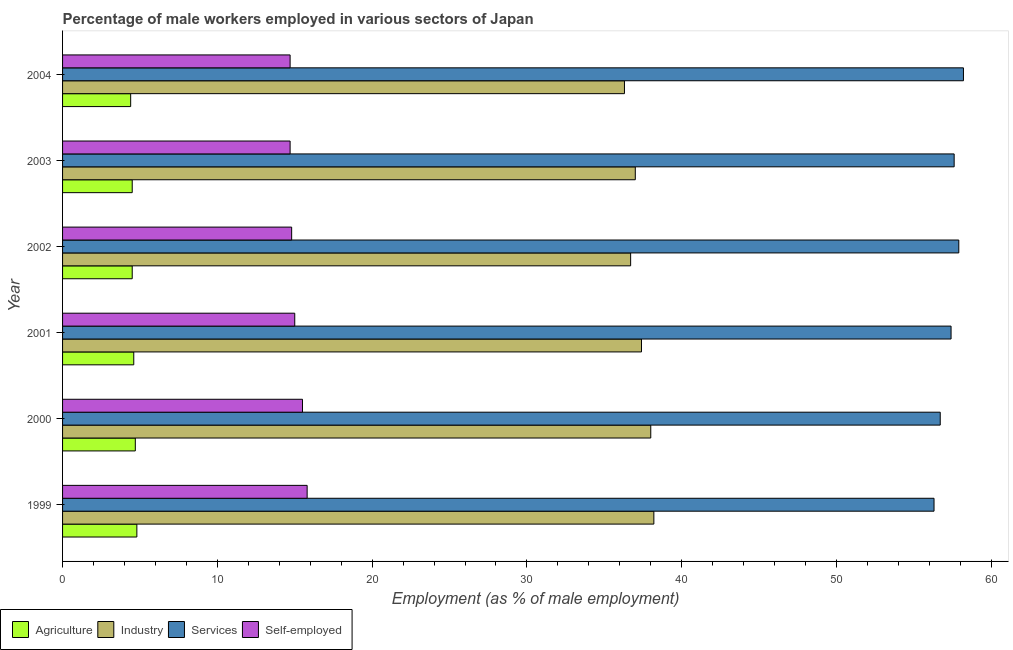How many groups of bars are there?
Your answer should be very brief. 6. Are the number of bars on each tick of the Y-axis equal?
Provide a succinct answer. Yes. What is the percentage of male workers in services in 2004?
Offer a very short reply. 58.2. Across all years, what is the maximum percentage of self employed male workers?
Give a very brief answer. 15.8. Across all years, what is the minimum percentage of male workers in agriculture?
Your answer should be compact. 4.4. In which year was the percentage of male workers in industry maximum?
Ensure brevity in your answer.  1999. What is the total percentage of male workers in agriculture in the graph?
Your answer should be compact. 27.5. What is the difference between the percentage of male workers in industry in 1999 and the percentage of male workers in services in 2001?
Ensure brevity in your answer.  -19.2. What is the average percentage of self employed male workers per year?
Provide a succinct answer. 15.08. In the year 2001, what is the difference between the percentage of male workers in agriculture and percentage of male workers in industry?
Your answer should be compact. -32.8. What is the ratio of the percentage of male workers in industry in 2002 to that in 2003?
Your answer should be very brief. 0.99. Is the percentage of self employed male workers in 1999 less than that in 2000?
Make the answer very short. No. In how many years, is the percentage of self employed male workers greater than the average percentage of self employed male workers taken over all years?
Offer a terse response. 2. Is the sum of the percentage of male workers in agriculture in 1999 and 2004 greater than the maximum percentage of male workers in industry across all years?
Offer a terse response. No. What does the 3rd bar from the top in 2003 represents?
Offer a very short reply. Industry. What does the 1st bar from the bottom in 2002 represents?
Provide a short and direct response. Agriculture. Is it the case that in every year, the sum of the percentage of male workers in agriculture and percentage of male workers in industry is greater than the percentage of male workers in services?
Your answer should be very brief. No. How many bars are there?
Your answer should be compact. 24. Are all the bars in the graph horizontal?
Provide a short and direct response. Yes. How many years are there in the graph?
Your response must be concise. 6. Does the graph contain grids?
Ensure brevity in your answer.  No. Where does the legend appear in the graph?
Provide a short and direct response. Bottom left. How many legend labels are there?
Ensure brevity in your answer.  4. How are the legend labels stacked?
Ensure brevity in your answer.  Horizontal. What is the title of the graph?
Offer a terse response. Percentage of male workers employed in various sectors of Japan. Does "Others" appear as one of the legend labels in the graph?
Give a very brief answer. No. What is the label or title of the X-axis?
Ensure brevity in your answer.  Employment (as % of male employment). What is the label or title of the Y-axis?
Ensure brevity in your answer.  Year. What is the Employment (as % of male employment) of Agriculture in 1999?
Provide a succinct answer. 4.8. What is the Employment (as % of male employment) in Industry in 1999?
Provide a succinct answer. 38.2. What is the Employment (as % of male employment) in Services in 1999?
Your answer should be very brief. 56.3. What is the Employment (as % of male employment) in Self-employed in 1999?
Make the answer very short. 15.8. What is the Employment (as % of male employment) in Agriculture in 2000?
Your answer should be very brief. 4.7. What is the Employment (as % of male employment) of Industry in 2000?
Provide a succinct answer. 38. What is the Employment (as % of male employment) in Services in 2000?
Ensure brevity in your answer.  56.7. What is the Employment (as % of male employment) in Self-employed in 2000?
Your answer should be very brief. 15.5. What is the Employment (as % of male employment) of Agriculture in 2001?
Ensure brevity in your answer.  4.6. What is the Employment (as % of male employment) in Industry in 2001?
Keep it short and to the point. 37.4. What is the Employment (as % of male employment) of Services in 2001?
Keep it short and to the point. 57.4. What is the Employment (as % of male employment) of Industry in 2002?
Provide a short and direct response. 36.7. What is the Employment (as % of male employment) in Services in 2002?
Provide a short and direct response. 57.9. What is the Employment (as % of male employment) in Self-employed in 2002?
Your answer should be compact. 14.8. What is the Employment (as % of male employment) in Industry in 2003?
Your answer should be compact. 37. What is the Employment (as % of male employment) of Services in 2003?
Give a very brief answer. 57.6. What is the Employment (as % of male employment) of Self-employed in 2003?
Ensure brevity in your answer.  14.7. What is the Employment (as % of male employment) of Agriculture in 2004?
Keep it short and to the point. 4.4. What is the Employment (as % of male employment) of Industry in 2004?
Make the answer very short. 36.3. What is the Employment (as % of male employment) of Services in 2004?
Offer a terse response. 58.2. What is the Employment (as % of male employment) of Self-employed in 2004?
Your response must be concise. 14.7. Across all years, what is the maximum Employment (as % of male employment) of Agriculture?
Offer a terse response. 4.8. Across all years, what is the maximum Employment (as % of male employment) of Industry?
Give a very brief answer. 38.2. Across all years, what is the maximum Employment (as % of male employment) of Services?
Provide a succinct answer. 58.2. Across all years, what is the maximum Employment (as % of male employment) of Self-employed?
Your response must be concise. 15.8. Across all years, what is the minimum Employment (as % of male employment) in Agriculture?
Your answer should be very brief. 4.4. Across all years, what is the minimum Employment (as % of male employment) in Industry?
Your response must be concise. 36.3. Across all years, what is the minimum Employment (as % of male employment) of Services?
Provide a succinct answer. 56.3. Across all years, what is the minimum Employment (as % of male employment) of Self-employed?
Offer a very short reply. 14.7. What is the total Employment (as % of male employment) of Industry in the graph?
Keep it short and to the point. 223.6. What is the total Employment (as % of male employment) in Services in the graph?
Your answer should be compact. 344.1. What is the total Employment (as % of male employment) in Self-employed in the graph?
Provide a succinct answer. 90.5. What is the difference between the Employment (as % of male employment) of Agriculture in 1999 and that in 2000?
Give a very brief answer. 0.1. What is the difference between the Employment (as % of male employment) of Self-employed in 1999 and that in 2000?
Ensure brevity in your answer.  0.3. What is the difference between the Employment (as % of male employment) of Self-employed in 1999 and that in 2001?
Provide a succinct answer. 0.8. What is the difference between the Employment (as % of male employment) of Agriculture in 1999 and that in 2002?
Your response must be concise. 0.3. What is the difference between the Employment (as % of male employment) in Industry in 1999 and that in 2002?
Ensure brevity in your answer.  1.5. What is the difference between the Employment (as % of male employment) of Services in 1999 and that in 2002?
Keep it short and to the point. -1.6. What is the difference between the Employment (as % of male employment) of Industry in 1999 and that in 2003?
Your answer should be compact. 1.2. What is the difference between the Employment (as % of male employment) of Self-employed in 1999 and that in 2003?
Give a very brief answer. 1.1. What is the difference between the Employment (as % of male employment) in Industry in 1999 and that in 2004?
Ensure brevity in your answer.  1.9. What is the difference between the Employment (as % of male employment) of Services in 1999 and that in 2004?
Provide a succinct answer. -1.9. What is the difference between the Employment (as % of male employment) in Self-employed in 1999 and that in 2004?
Provide a succinct answer. 1.1. What is the difference between the Employment (as % of male employment) in Agriculture in 2000 and that in 2001?
Your response must be concise. 0.1. What is the difference between the Employment (as % of male employment) of Industry in 2000 and that in 2001?
Your response must be concise. 0.6. What is the difference between the Employment (as % of male employment) in Services in 2000 and that in 2001?
Provide a short and direct response. -0.7. What is the difference between the Employment (as % of male employment) of Self-employed in 2000 and that in 2001?
Make the answer very short. 0.5. What is the difference between the Employment (as % of male employment) of Industry in 2000 and that in 2002?
Give a very brief answer. 1.3. What is the difference between the Employment (as % of male employment) in Services in 2000 and that in 2002?
Offer a very short reply. -1.2. What is the difference between the Employment (as % of male employment) in Self-employed in 2000 and that in 2002?
Make the answer very short. 0.7. What is the difference between the Employment (as % of male employment) in Services in 2000 and that in 2003?
Your answer should be compact. -0.9. What is the difference between the Employment (as % of male employment) of Self-employed in 2000 and that in 2003?
Ensure brevity in your answer.  0.8. What is the difference between the Employment (as % of male employment) in Services in 2000 and that in 2004?
Provide a short and direct response. -1.5. What is the difference between the Employment (as % of male employment) in Self-employed in 2001 and that in 2002?
Provide a short and direct response. 0.2. What is the difference between the Employment (as % of male employment) in Industry in 2001 and that in 2003?
Give a very brief answer. 0.4. What is the difference between the Employment (as % of male employment) in Services in 2001 and that in 2003?
Give a very brief answer. -0.2. What is the difference between the Employment (as % of male employment) of Agriculture in 2001 and that in 2004?
Provide a short and direct response. 0.2. What is the difference between the Employment (as % of male employment) of Industry in 2001 and that in 2004?
Provide a short and direct response. 1.1. What is the difference between the Employment (as % of male employment) of Self-employed in 2001 and that in 2004?
Provide a short and direct response. 0.3. What is the difference between the Employment (as % of male employment) in Industry in 2002 and that in 2003?
Your answer should be compact. -0.3. What is the difference between the Employment (as % of male employment) in Services in 2002 and that in 2003?
Provide a succinct answer. 0.3. What is the difference between the Employment (as % of male employment) of Agriculture in 2002 and that in 2004?
Keep it short and to the point. 0.1. What is the difference between the Employment (as % of male employment) in Industry in 2002 and that in 2004?
Provide a short and direct response. 0.4. What is the difference between the Employment (as % of male employment) of Services in 2002 and that in 2004?
Provide a short and direct response. -0.3. What is the difference between the Employment (as % of male employment) in Industry in 2003 and that in 2004?
Offer a terse response. 0.7. What is the difference between the Employment (as % of male employment) of Services in 2003 and that in 2004?
Give a very brief answer. -0.6. What is the difference between the Employment (as % of male employment) in Agriculture in 1999 and the Employment (as % of male employment) in Industry in 2000?
Keep it short and to the point. -33.2. What is the difference between the Employment (as % of male employment) in Agriculture in 1999 and the Employment (as % of male employment) in Services in 2000?
Ensure brevity in your answer.  -51.9. What is the difference between the Employment (as % of male employment) in Industry in 1999 and the Employment (as % of male employment) in Services in 2000?
Make the answer very short. -18.5. What is the difference between the Employment (as % of male employment) in Industry in 1999 and the Employment (as % of male employment) in Self-employed in 2000?
Your response must be concise. 22.7. What is the difference between the Employment (as % of male employment) of Services in 1999 and the Employment (as % of male employment) of Self-employed in 2000?
Your response must be concise. 40.8. What is the difference between the Employment (as % of male employment) of Agriculture in 1999 and the Employment (as % of male employment) of Industry in 2001?
Ensure brevity in your answer.  -32.6. What is the difference between the Employment (as % of male employment) in Agriculture in 1999 and the Employment (as % of male employment) in Services in 2001?
Offer a terse response. -52.6. What is the difference between the Employment (as % of male employment) of Industry in 1999 and the Employment (as % of male employment) of Services in 2001?
Give a very brief answer. -19.2. What is the difference between the Employment (as % of male employment) in Industry in 1999 and the Employment (as % of male employment) in Self-employed in 2001?
Provide a succinct answer. 23.2. What is the difference between the Employment (as % of male employment) of Services in 1999 and the Employment (as % of male employment) of Self-employed in 2001?
Provide a short and direct response. 41.3. What is the difference between the Employment (as % of male employment) of Agriculture in 1999 and the Employment (as % of male employment) of Industry in 2002?
Keep it short and to the point. -31.9. What is the difference between the Employment (as % of male employment) in Agriculture in 1999 and the Employment (as % of male employment) in Services in 2002?
Your answer should be compact. -53.1. What is the difference between the Employment (as % of male employment) in Agriculture in 1999 and the Employment (as % of male employment) in Self-employed in 2002?
Keep it short and to the point. -10. What is the difference between the Employment (as % of male employment) in Industry in 1999 and the Employment (as % of male employment) in Services in 2002?
Keep it short and to the point. -19.7. What is the difference between the Employment (as % of male employment) in Industry in 1999 and the Employment (as % of male employment) in Self-employed in 2002?
Offer a very short reply. 23.4. What is the difference between the Employment (as % of male employment) of Services in 1999 and the Employment (as % of male employment) of Self-employed in 2002?
Provide a succinct answer. 41.5. What is the difference between the Employment (as % of male employment) of Agriculture in 1999 and the Employment (as % of male employment) of Industry in 2003?
Your answer should be very brief. -32.2. What is the difference between the Employment (as % of male employment) in Agriculture in 1999 and the Employment (as % of male employment) in Services in 2003?
Your answer should be very brief. -52.8. What is the difference between the Employment (as % of male employment) of Industry in 1999 and the Employment (as % of male employment) of Services in 2003?
Your answer should be very brief. -19.4. What is the difference between the Employment (as % of male employment) in Industry in 1999 and the Employment (as % of male employment) in Self-employed in 2003?
Provide a succinct answer. 23.5. What is the difference between the Employment (as % of male employment) of Services in 1999 and the Employment (as % of male employment) of Self-employed in 2003?
Make the answer very short. 41.6. What is the difference between the Employment (as % of male employment) of Agriculture in 1999 and the Employment (as % of male employment) of Industry in 2004?
Keep it short and to the point. -31.5. What is the difference between the Employment (as % of male employment) in Agriculture in 1999 and the Employment (as % of male employment) in Services in 2004?
Give a very brief answer. -53.4. What is the difference between the Employment (as % of male employment) in Industry in 1999 and the Employment (as % of male employment) in Services in 2004?
Keep it short and to the point. -20. What is the difference between the Employment (as % of male employment) in Services in 1999 and the Employment (as % of male employment) in Self-employed in 2004?
Your response must be concise. 41.6. What is the difference between the Employment (as % of male employment) of Agriculture in 2000 and the Employment (as % of male employment) of Industry in 2001?
Offer a very short reply. -32.7. What is the difference between the Employment (as % of male employment) in Agriculture in 2000 and the Employment (as % of male employment) in Services in 2001?
Provide a succinct answer. -52.7. What is the difference between the Employment (as % of male employment) of Agriculture in 2000 and the Employment (as % of male employment) of Self-employed in 2001?
Offer a terse response. -10.3. What is the difference between the Employment (as % of male employment) of Industry in 2000 and the Employment (as % of male employment) of Services in 2001?
Ensure brevity in your answer.  -19.4. What is the difference between the Employment (as % of male employment) in Industry in 2000 and the Employment (as % of male employment) in Self-employed in 2001?
Give a very brief answer. 23. What is the difference between the Employment (as % of male employment) of Services in 2000 and the Employment (as % of male employment) of Self-employed in 2001?
Give a very brief answer. 41.7. What is the difference between the Employment (as % of male employment) in Agriculture in 2000 and the Employment (as % of male employment) in Industry in 2002?
Offer a very short reply. -32. What is the difference between the Employment (as % of male employment) in Agriculture in 2000 and the Employment (as % of male employment) in Services in 2002?
Give a very brief answer. -53.2. What is the difference between the Employment (as % of male employment) of Agriculture in 2000 and the Employment (as % of male employment) of Self-employed in 2002?
Your response must be concise. -10.1. What is the difference between the Employment (as % of male employment) of Industry in 2000 and the Employment (as % of male employment) of Services in 2002?
Offer a terse response. -19.9. What is the difference between the Employment (as % of male employment) in Industry in 2000 and the Employment (as % of male employment) in Self-employed in 2002?
Ensure brevity in your answer.  23.2. What is the difference between the Employment (as % of male employment) of Services in 2000 and the Employment (as % of male employment) of Self-employed in 2002?
Your response must be concise. 41.9. What is the difference between the Employment (as % of male employment) of Agriculture in 2000 and the Employment (as % of male employment) of Industry in 2003?
Provide a short and direct response. -32.3. What is the difference between the Employment (as % of male employment) of Agriculture in 2000 and the Employment (as % of male employment) of Services in 2003?
Offer a terse response. -52.9. What is the difference between the Employment (as % of male employment) in Agriculture in 2000 and the Employment (as % of male employment) in Self-employed in 2003?
Keep it short and to the point. -10. What is the difference between the Employment (as % of male employment) of Industry in 2000 and the Employment (as % of male employment) of Services in 2003?
Your answer should be compact. -19.6. What is the difference between the Employment (as % of male employment) of Industry in 2000 and the Employment (as % of male employment) of Self-employed in 2003?
Offer a terse response. 23.3. What is the difference between the Employment (as % of male employment) of Services in 2000 and the Employment (as % of male employment) of Self-employed in 2003?
Keep it short and to the point. 42. What is the difference between the Employment (as % of male employment) of Agriculture in 2000 and the Employment (as % of male employment) of Industry in 2004?
Provide a succinct answer. -31.6. What is the difference between the Employment (as % of male employment) of Agriculture in 2000 and the Employment (as % of male employment) of Services in 2004?
Make the answer very short. -53.5. What is the difference between the Employment (as % of male employment) of Industry in 2000 and the Employment (as % of male employment) of Services in 2004?
Offer a very short reply. -20.2. What is the difference between the Employment (as % of male employment) in Industry in 2000 and the Employment (as % of male employment) in Self-employed in 2004?
Keep it short and to the point. 23.3. What is the difference between the Employment (as % of male employment) in Services in 2000 and the Employment (as % of male employment) in Self-employed in 2004?
Keep it short and to the point. 42. What is the difference between the Employment (as % of male employment) in Agriculture in 2001 and the Employment (as % of male employment) in Industry in 2002?
Provide a short and direct response. -32.1. What is the difference between the Employment (as % of male employment) of Agriculture in 2001 and the Employment (as % of male employment) of Services in 2002?
Ensure brevity in your answer.  -53.3. What is the difference between the Employment (as % of male employment) of Agriculture in 2001 and the Employment (as % of male employment) of Self-employed in 2002?
Your response must be concise. -10.2. What is the difference between the Employment (as % of male employment) of Industry in 2001 and the Employment (as % of male employment) of Services in 2002?
Offer a very short reply. -20.5. What is the difference between the Employment (as % of male employment) in Industry in 2001 and the Employment (as % of male employment) in Self-employed in 2002?
Give a very brief answer. 22.6. What is the difference between the Employment (as % of male employment) in Services in 2001 and the Employment (as % of male employment) in Self-employed in 2002?
Provide a short and direct response. 42.6. What is the difference between the Employment (as % of male employment) of Agriculture in 2001 and the Employment (as % of male employment) of Industry in 2003?
Your answer should be compact. -32.4. What is the difference between the Employment (as % of male employment) of Agriculture in 2001 and the Employment (as % of male employment) of Services in 2003?
Your answer should be very brief. -53. What is the difference between the Employment (as % of male employment) in Industry in 2001 and the Employment (as % of male employment) in Services in 2003?
Give a very brief answer. -20.2. What is the difference between the Employment (as % of male employment) in Industry in 2001 and the Employment (as % of male employment) in Self-employed in 2003?
Keep it short and to the point. 22.7. What is the difference between the Employment (as % of male employment) of Services in 2001 and the Employment (as % of male employment) of Self-employed in 2003?
Ensure brevity in your answer.  42.7. What is the difference between the Employment (as % of male employment) in Agriculture in 2001 and the Employment (as % of male employment) in Industry in 2004?
Provide a short and direct response. -31.7. What is the difference between the Employment (as % of male employment) in Agriculture in 2001 and the Employment (as % of male employment) in Services in 2004?
Provide a succinct answer. -53.6. What is the difference between the Employment (as % of male employment) of Industry in 2001 and the Employment (as % of male employment) of Services in 2004?
Provide a short and direct response. -20.8. What is the difference between the Employment (as % of male employment) in Industry in 2001 and the Employment (as % of male employment) in Self-employed in 2004?
Keep it short and to the point. 22.7. What is the difference between the Employment (as % of male employment) of Services in 2001 and the Employment (as % of male employment) of Self-employed in 2004?
Offer a terse response. 42.7. What is the difference between the Employment (as % of male employment) in Agriculture in 2002 and the Employment (as % of male employment) in Industry in 2003?
Your answer should be compact. -32.5. What is the difference between the Employment (as % of male employment) in Agriculture in 2002 and the Employment (as % of male employment) in Services in 2003?
Your answer should be compact. -53.1. What is the difference between the Employment (as % of male employment) of Agriculture in 2002 and the Employment (as % of male employment) of Self-employed in 2003?
Make the answer very short. -10.2. What is the difference between the Employment (as % of male employment) in Industry in 2002 and the Employment (as % of male employment) in Services in 2003?
Your answer should be very brief. -20.9. What is the difference between the Employment (as % of male employment) in Services in 2002 and the Employment (as % of male employment) in Self-employed in 2003?
Give a very brief answer. 43.2. What is the difference between the Employment (as % of male employment) in Agriculture in 2002 and the Employment (as % of male employment) in Industry in 2004?
Offer a terse response. -31.8. What is the difference between the Employment (as % of male employment) of Agriculture in 2002 and the Employment (as % of male employment) of Services in 2004?
Your answer should be compact. -53.7. What is the difference between the Employment (as % of male employment) of Agriculture in 2002 and the Employment (as % of male employment) of Self-employed in 2004?
Make the answer very short. -10.2. What is the difference between the Employment (as % of male employment) in Industry in 2002 and the Employment (as % of male employment) in Services in 2004?
Your answer should be compact. -21.5. What is the difference between the Employment (as % of male employment) in Industry in 2002 and the Employment (as % of male employment) in Self-employed in 2004?
Your answer should be compact. 22. What is the difference between the Employment (as % of male employment) of Services in 2002 and the Employment (as % of male employment) of Self-employed in 2004?
Provide a short and direct response. 43.2. What is the difference between the Employment (as % of male employment) of Agriculture in 2003 and the Employment (as % of male employment) of Industry in 2004?
Your answer should be compact. -31.8. What is the difference between the Employment (as % of male employment) of Agriculture in 2003 and the Employment (as % of male employment) of Services in 2004?
Your response must be concise. -53.7. What is the difference between the Employment (as % of male employment) of Agriculture in 2003 and the Employment (as % of male employment) of Self-employed in 2004?
Your answer should be compact. -10.2. What is the difference between the Employment (as % of male employment) of Industry in 2003 and the Employment (as % of male employment) of Services in 2004?
Offer a terse response. -21.2. What is the difference between the Employment (as % of male employment) in Industry in 2003 and the Employment (as % of male employment) in Self-employed in 2004?
Provide a short and direct response. 22.3. What is the difference between the Employment (as % of male employment) of Services in 2003 and the Employment (as % of male employment) of Self-employed in 2004?
Your answer should be very brief. 42.9. What is the average Employment (as % of male employment) in Agriculture per year?
Give a very brief answer. 4.58. What is the average Employment (as % of male employment) of Industry per year?
Make the answer very short. 37.27. What is the average Employment (as % of male employment) of Services per year?
Provide a short and direct response. 57.35. What is the average Employment (as % of male employment) of Self-employed per year?
Keep it short and to the point. 15.08. In the year 1999, what is the difference between the Employment (as % of male employment) of Agriculture and Employment (as % of male employment) of Industry?
Keep it short and to the point. -33.4. In the year 1999, what is the difference between the Employment (as % of male employment) of Agriculture and Employment (as % of male employment) of Services?
Offer a very short reply. -51.5. In the year 1999, what is the difference between the Employment (as % of male employment) in Industry and Employment (as % of male employment) in Services?
Provide a short and direct response. -18.1. In the year 1999, what is the difference between the Employment (as % of male employment) in Industry and Employment (as % of male employment) in Self-employed?
Your response must be concise. 22.4. In the year 1999, what is the difference between the Employment (as % of male employment) of Services and Employment (as % of male employment) of Self-employed?
Offer a very short reply. 40.5. In the year 2000, what is the difference between the Employment (as % of male employment) of Agriculture and Employment (as % of male employment) of Industry?
Make the answer very short. -33.3. In the year 2000, what is the difference between the Employment (as % of male employment) of Agriculture and Employment (as % of male employment) of Services?
Keep it short and to the point. -52. In the year 2000, what is the difference between the Employment (as % of male employment) of Industry and Employment (as % of male employment) of Services?
Your response must be concise. -18.7. In the year 2000, what is the difference between the Employment (as % of male employment) in Industry and Employment (as % of male employment) in Self-employed?
Your answer should be compact. 22.5. In the year 2000, what is the difference between the Employment (as % of male employment) of Services and Employment (as % of male employment) of Self-employed?
Ensure brevity in your answer.  41.2. In the year 2001, what is the difference between the Employment (as % of male employment) of Agriculture and Employment (as % of male employment) of Industry?
Provide a succinct answer. -32.8. In the year 2001, what is the difference between the Employment (as % of male employment) of Agriculture and Employment (as % of male employment) of Services?
Provide a short and direct response. -52.8. In the year 2001, what is the difference between the Employment (as % of male employment) of Agriculture and Employment (as % of male employment) of Self-employed?
Make the answer very short. -10.4. In the year 2001, what is the difference between the Employment (as % of male employment) in Industry and Employment (as % of male employment) in Self-employed?
Your response must be concise. 22.4. In the year 2001, what is the difference between the Employment (as % of male employment) of Services and Employment (as % of male employment) of Self-employed?
Offer a very short reply. 42.4. In the year 2002, what is the difference between the Employment (as % of male employment) in Agriculture and Employment (as % of male employment) in Industry?
Offer a very short reply. -32.2. In the year 2002, what is the difference between the Employment (as % of male employment) of Agriculture and Employment (as % of male employment) of Services?
Keep it short and to the point. -53.4. In the year 2002, what is the difference between the Employment (as % of male employment) of Agriculture and Employment (as % of male employment) of Self-employed?
Keep it short and to the point. -10.3. In the year 2002, what is the difference between the Employment (as % of male employment) of Industry and Employment (as % of male employment) of Services?
Provide a short and direct response. -21.2. In the year 2002, what is the difference between the Employment (as % of male employment) in Industry and Employment (as % of male employment) in Self-employed?
Your answer should be compact. 21.9. In the year 2002, what is the difference between the Employment (as % of male employment) in Services and Employment (as % of male employment) in Self-employed?
Keep it short and to the point. 43.1. In the year 2003, what is the difference between the Employment (as % of male employment) in Agriculture and Employment (as % of male employment) in Industry?
Your answer should be very brief. -32.5. In the year 2003, what is the difference between the Employment (as % of male employment) in Agriculture and Employment (as % of male employment) in Services?
Ensure brevity in your answer.  -53.1. In the year 2003, what is the difference between the Employment (as % of male employment) of Agriculture and Employment (as % of male employment) of Self-employed?
Keep it short and to the point. -10.2. In the year 2003, what is the difference between the Employment (as % of male employment) in Industry and Employment (as % of male employment) in Services?
Offer a very short reply. -20.6. In the year 2003, what is the difference between the Employment (as % of male employment) in Industry and Employment (as % of male employment) in Self-employed?
Offer a terse response. 22.3. In the year 2003, what is the difference between the Employment (as % of male employment) of Services and Employment (as % of male employment) of Self-employed?
Offer a very short reply. 42.9. In the year 2004, what is the difference between the Employment (as % of male employment) in Agriculture and Employment (as % of male employment) in Industry?
Make the answer very short. -31.9. In the year 2004, what is the difference between the Employment (as % of male employment) in Agriculture and Employment (as % of male employment) in Services?
Give a very brief answer. -53.8. In the year 2004, what is the difference between the Employment (as % of male employment) in Agriculture and Employment (as % of male employment) in Self-employed?
Your answer should be very brief. -10.3. In the year 2004, what is the difference between the Employment (as % of male employment) of Industry and Employment (as % of male employment) of Services?
Your answer should be very brief. -21.9. In the year 2004, what is the difference between the Employment (as % of male employment) in Industry and Employment (as % of male employment) in Self-employed?
Keep it short and to the point. 21.6. In the year 2004, what is the difference between the Employment (as % of male employment) of Services and Employment (as % of male employment) of Self-employed?
Offer a very short reply. 43.5. What is the ratio of the Employment (as % of male employment) in Agriculture in 1999 to that in 2000?
Ensure brevity in your answer.  1.02. What is the ratio of the Employment (as % of male employment) of Services in 1999 to that in 2000?
Your answer should be very brief. 0.99. What is the ratio of the Employment (as % of male employment) in Self-employed in 1999 to that in 2000?
Make the answer very short. 1.02. What is the ratio of the Employment (as % of male employment) in Agriculture in 1999 to that in 2001?
Offer a terse response. 1.04. What is the ratio of the Employment (as % of male employment) of Industry in 1999 to that in 2001?
Keep it short and to the point. 1.02. What is the ratio of the Employment (as % of male employment) of Services in 1999 to that in 2001?
Ensure brevity in your answer.  0.98. What is the ratio of the Employment (as % of male employment) of Self-employed in 1999 to that in 2001?
Your response must be concise. 1.05. What is the ratio of the Employment (as % of male employment) in Agriculture in 1999 to that in 2002?
Your answer should be compact. 1.07. What is the ratio of the Employment (as % of male employment) of Industry in 1999 to that in 2002?
Keep it short and to the point. 1.04. What is the ratio of the Employment (as % of male employment) in Services in 1999 to that in 2002?
Your answer should be compact. 0.97. What is the ratio of the Employment (as % of male employment) of Self-employed in 1999 to that in 2002?
Keep it short and to the point. 1.07. What is the ratio of the Employment (as % of male employment) of Agriculture in 1999 to that in 2003?
Offer a very short reply. 1.07. What is the ratio of the Employment (as % of male employment) in Industry in 1999 to that in 2003?
Ensure brevity in your answer.  1.03. What is the ratio of the Employment (as % of male employment) in Services in 1999 to that in 2003?
Provide a short and direct response. 0.98. What is the ratio of the Employment (as % of male employment) in Self-employed in 1999 to that in 2003?
Your response must be concise. 1.07. What is the ratio of the Employment (as % of male employment) of Agriculture in 1999 to that in 2004?
Ensure brevity in your answer.  1.09. What is the ratio of the Employment (as % of male employment) in Industry in 1999 to that in 2004?
Your answer should be very brief. 1.05. What is the ratio of the Employment (as % of male employment) of Services in 1999 to that in 2004?
Your response must be concise. 0.97. What is the ratio of the Employment (as % of male employment) of Self-employed in 1999 to that in 2004?
Make the answer very short. 1.07. What is the ratio of the Employment (as % of male employment) of Agriculture in 2000 to that in 2001?
Provide a succinct answer. 1.02. What is the ratio of the Employment (as % of male employment) in Services in 2000 to that in 2001?
Provide a short and direct response. 0.99. What is the ratio of the Employment (as % of male employment) of Self-employed in 2000 to that in 2001?
Your response must be concise. 1.03. What is the ratio of the Employment (as % of male employment) of Agriculture in 2000 to that in 2002?
Provide a short and direct response. 1.04. What is the ratio of the Employment (as % of male employment) of Industry in 2000 to that in 2002?
Keep it short and to the point. 1.04. What is the ratio of the Employment (as % of male employment) of Services in 2000 to that in 2002?
Your answer should be compact. 0.98. What is the ratio of the Employment (as % of male employment) of Self-employed in 2000 to that in 2002?
Your answer should be compact. 1.05. What is the ratio of the Employment (as % of male employment) of Agriculture in 2000 to that in 2003?
Provide a succinct answer. 1.04. What is the ratio of the Employment (as % of male employment) in Industry in 2000 to that in 2003?
Your answer should be very brief. 1.03. What is the ratio of the Employment (as % of male employment) of Services in 2000 to that in 2003?
Offer a terse response. 0.98. What is the ratio of the Employment (as % of male employment) in Self-employed in 2000 to that in 2003?
Offer a very short reply. 1.05. What is the ratio of the Employment (as % of male employment) of Agriculture in 2000 to that in 2004?
Keep it short and to the point. 1.07. What is the ratio of the Employment (as % of male employment) of Industry in 2000 to that in 2004?
Your response must be concise. 1.05. What is the ratio of the Employment (as % of male employment) in Services in 2000 to that in 2004?
Provide a succinct answer. 0.97. What is the ratio of the Employment (as % of male employment) of Self-employed in 2000 to that in 2004?
Your response must be concise. 1.05. What is the ratio of the Employment (as % of male employment) in Agriculture in 2001 to that in 2002?
Your answer should be very brief. 1.02. What is the ratio of the Employment (as % of male employment) of Industry in 2001 to that in 2002?
Your answer should be very brief. 1.02. What is the ratio of the Employment (as % of male employment) of Services in 2001 to that in 2002?
Provide a succinct answer. 0.99. What is the ratio of the Employment (as % of male employment) in Self-employed in 2001 to that in 2002?
Offer a very short reply. 1.01. What is the ratio of the Employment (as % of male employment) in Agriculture in 2001 to that in 2003?
Make the answer very short. 1.02. What is the ratio of the Employment (as % of male employment) of Industry in 2001 to that in 2003?
Provide a short and direct response. 1.01. What is the ratio of the Employment (as % of male employment) of Services in 2001 to that in 2003?
Offer a very short reply. 1. What is the ratio of the Employment (as % of male employment) in Self-employed in 2001 to that in 2003?
Your response must be concise. 1.02. What is the ratio of the Employment (as % of male employment) of Agriculture in 2001 to that in 2004?
Offer a terse response. 1.05. What is the ratio of the Employment (as % of male employment) of Industry in 2001 to that in 2004?
Provide a short and direct response. 1.03. What is the ratio of the Employment (as % of male employment) of Services in 2001 to that in 2004?
Your response must be concise. 0.99. What is the ratio of the Employment (as % of male employment) in Self-employed in 2001 to that in 2004?
Offer a terse response. 1.02. What is the ratio of the Employment (as % of male employment) of Agriculture in 2002 to that in 2003?
Make the answer very short. 1. What is the ratio of the Employment (as % of male employment) in Industry in 2002 to that in 2003?
Your answer should be compact. 0.99. What is the ratio of the Employment (as % of male employment) of Self-employed in 2002 to that in 2003?
Keep it short and to the point. 1.01. What is the ratio of the Employment (as % of male employment) of Agriculture in 2002 to that in 2004?
Offer a terse response. 1.02. What is the ratio of the Employment (as % of male employment) in Self-employed in 2002 to that in 2004?
Your response must be concise. 1.01. What is the ratio of the Employment (as % of male employment) of Agriculture in 2003 to that in 2004?
Your response must be concise. 1.02. What is the ratio of the Employment (as % of male employment) in Industry in 2003 to that in 2004?
Keep it short and to the point. 1.02. What is the ratio of the Employment (as % of male employment) of Services in 2003 to that in 2004?
Make the answer very short. 0.99. What is the difference between the highest and the second highest Employment (as % of male employment) in Agriculture?
Offer a terse response. 0.1. What is the difference between the highest and the second highest Employment (as % of male employment) in Services?
Make the answer very short. 0.3. What is the difference between the highest and the second highest Employment (as % of male employment) in Self-employed?
Ensure brevity in your answer.  0.3. What is the difference between the highest and the lowest Employment (as % of male employment) in Industry?
Keep it short and to the point. 1.9. What is the difference between the highest and the lowest Employment (as % of male employment) of Self-employed?
Provide a succinct answer. 1.1. 